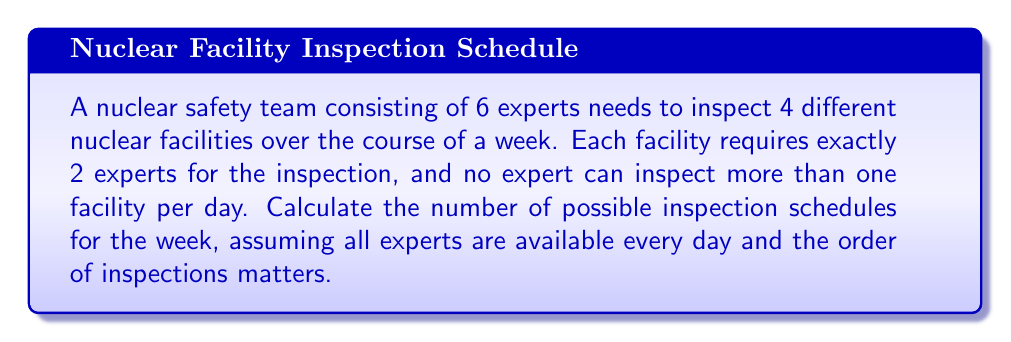Can you answer this question? Let's approach this problem step-by-step:

1) First, we need to choose which 2 experts will inspect each facility. This is a combination problem.
   For each facility, we choose 2 experts out of 6:
   $$\binom{6}{2} = \frac{6!}{2!(6-2)!} = \frac{6 \cdot 5}{2} = 15$$

2) We need to do this for all 4 facilities. Since the choices for each facility are independent, we multiply:
   $$15 \cdot 15 \cdot 15 \cdot 15 = 15^4 = 50,625$$

3) Now, we need to consider the order of inspections. This is a permutation of 4 facilities:
   $$4! = 4 \cdot 3 \cdot 2 \cdot 1 = 24$$

4) By the multiplication principle, we multiply the number of ways to choose experts for each facility by the number of ways to order the inspections:
   $$50,625 \cdot 24 = 1,215,000$$

Therefore, there are 1,215,000 possible inspection schedules for the week.
Answer: 1,215,000 possible inspection schedules 